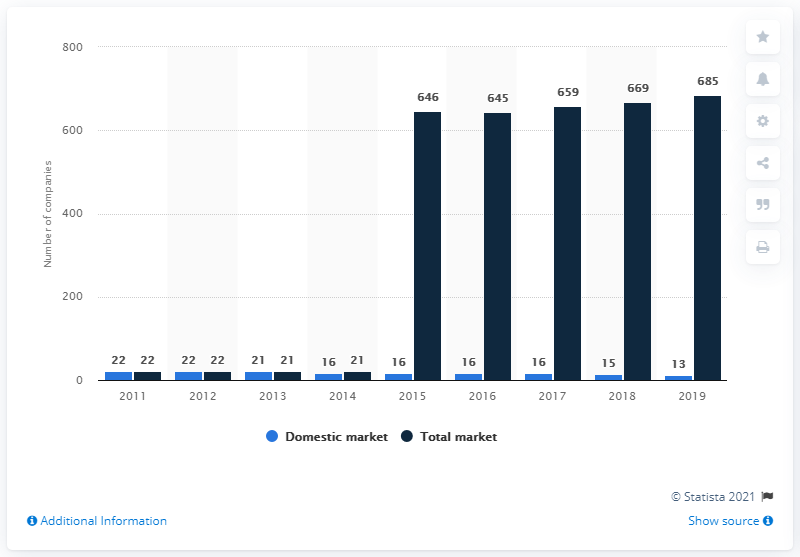Highlight a few significant elements in this photo. In 2019, a total of 685 companies were active in Slovakia's insurance market. As of the end of 2019, there were a total of 13 insurance companies operating on Slovakia's market. 